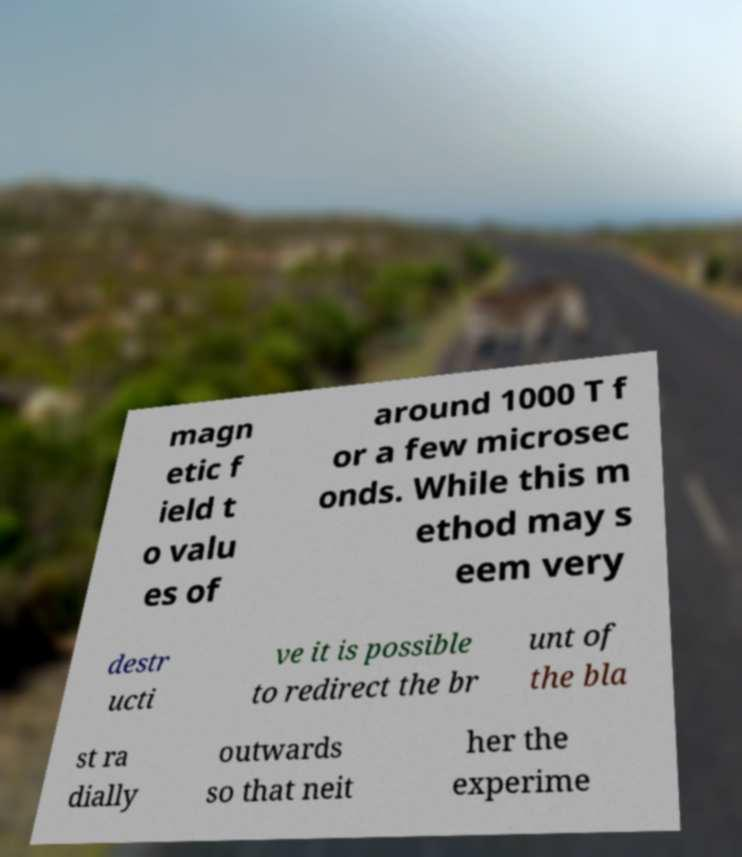For documentation purposes, I need the text within this image transcribed. Could you provide that? magn etic f ield t o valu es of around 1000 T f or a few microsec onds. While this m ethod may s eem very destr ucti ve it is possible to redirect the br unt of the bla st ra dially outwards so that neit her the experime 